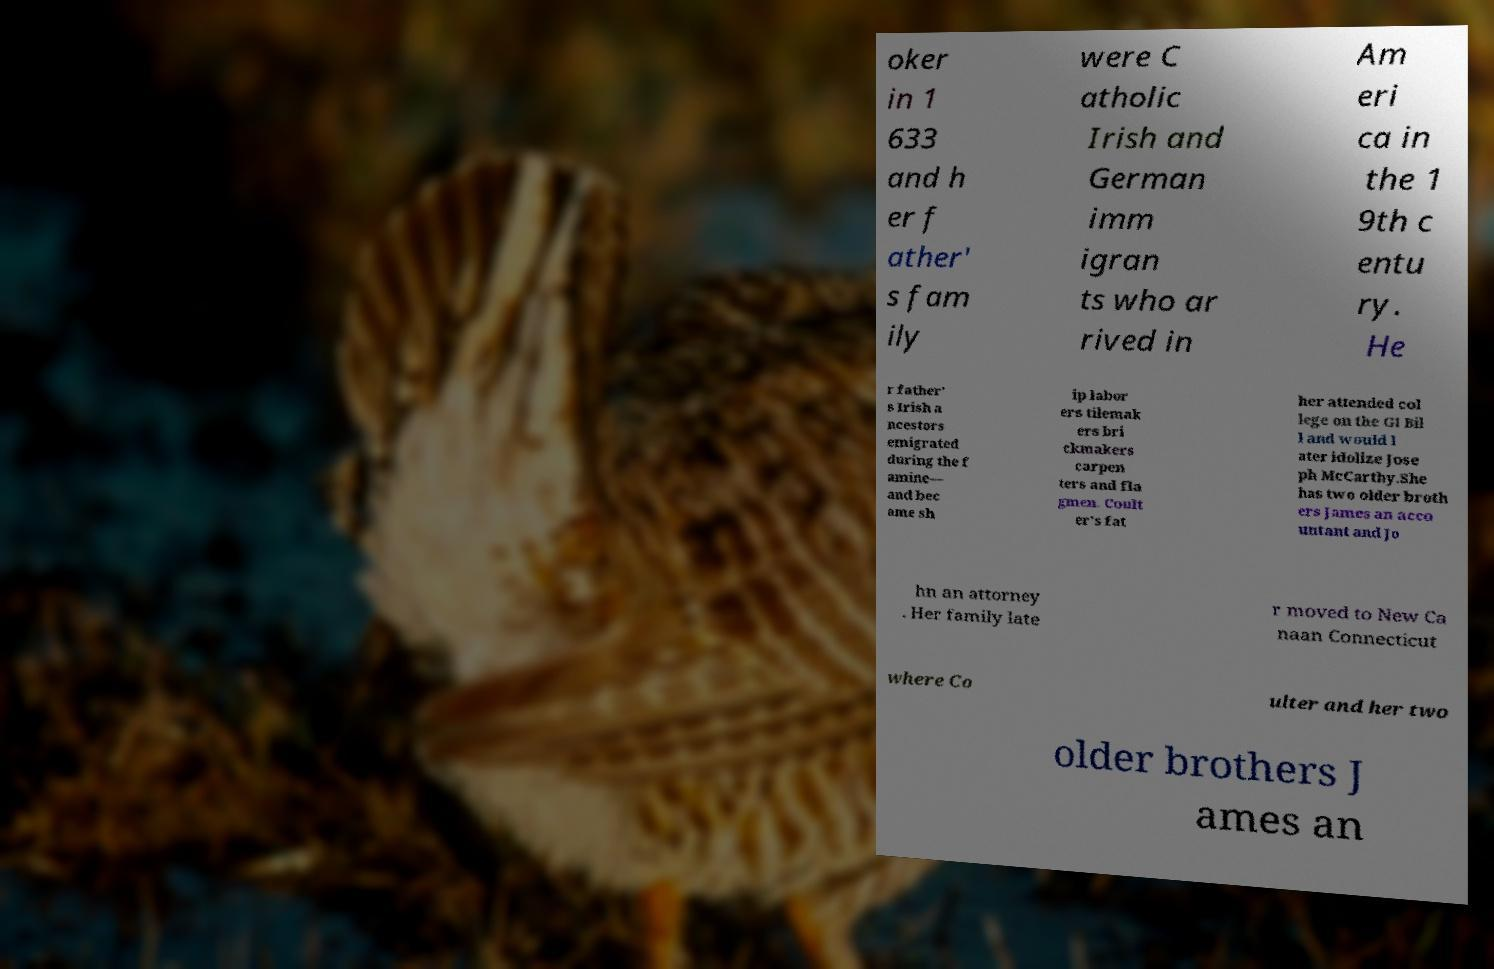For documentation purposes, I need the text within this image transcribed. Could you provide that? oker in 1 633 and h er f ather' s fam ily were C atholic Irish and German imm igran ts who ar rived in Am eri ca in the 1 9th c entu ry. He r father' s Irish a ncestors emigrated during the f amine— and bec ame sh ip labor ers tilemak ers bri ckmakers carpen ters and fla gmen. Coult er's fat her attended col lege on the GI Bil l and would l ater idolize Jose ph McCarthy.She has two older broth ers James an acco untant and Jo hn an attorney . Her family late r moved to New Ca naan Connecticut where Co ulter and her two older brothers J ames an 